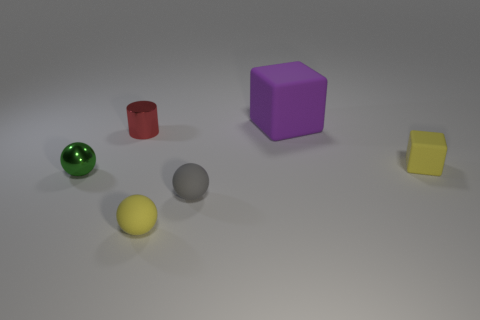Add 1 red shiny things. How many objects exist? 7 Subtract all cylinders. How many objects are left? 5 Subtract all large red matte spheres. Subtract all small gray objects. How many objects are left? 5 Add 5 shiny things. How many shiny things are left? 7 Add 3 big blue cylinders. How many big blue cylinders exist? 3 Subtract 0 brown blocks. How many objects are left? 6 